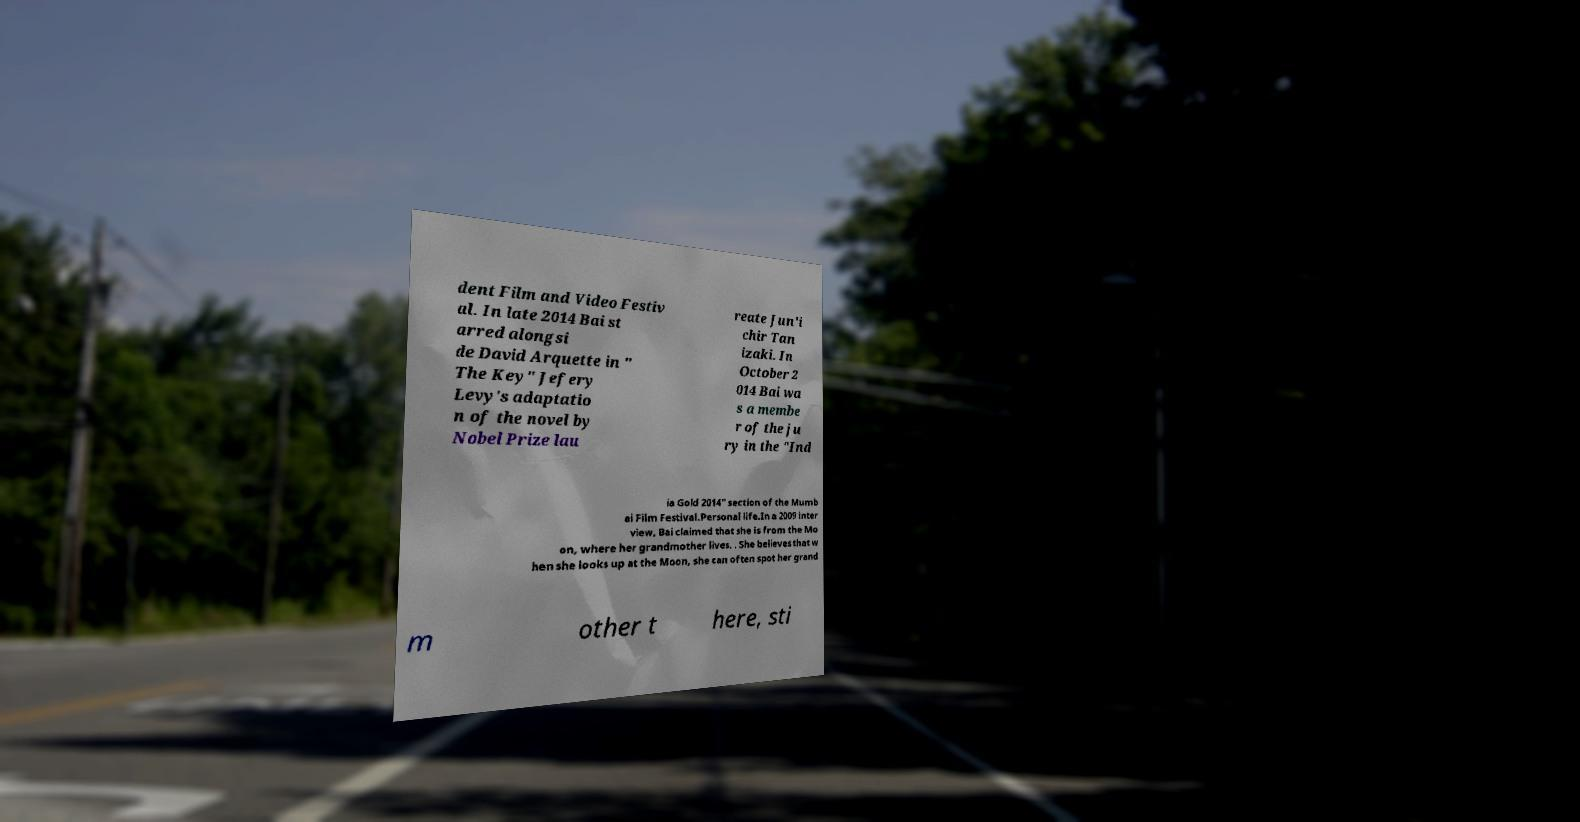There's text embedded in this image that I need extracted. Can you transcribe it verbatim? dent Film and Video Festiv al. In late 2014 Bai st arred alongsi de David Arquette in " The Key" Jefery Levy's adaptatio n of the novel by Nobel Prize lau reate Jun'i chir Tan izaki. In October 2 014 Bai wa s a membe r of the ju ry in the "Ind ia Gold 2014" section of the Mumb ai Film Festival.Personal life.In a 2009 inter view, Bai claimed that she is from the Mo on, where her grandmother lives. . She believes that w hen she looks up at the Moon, she can often spot her grand m other t here, sti 